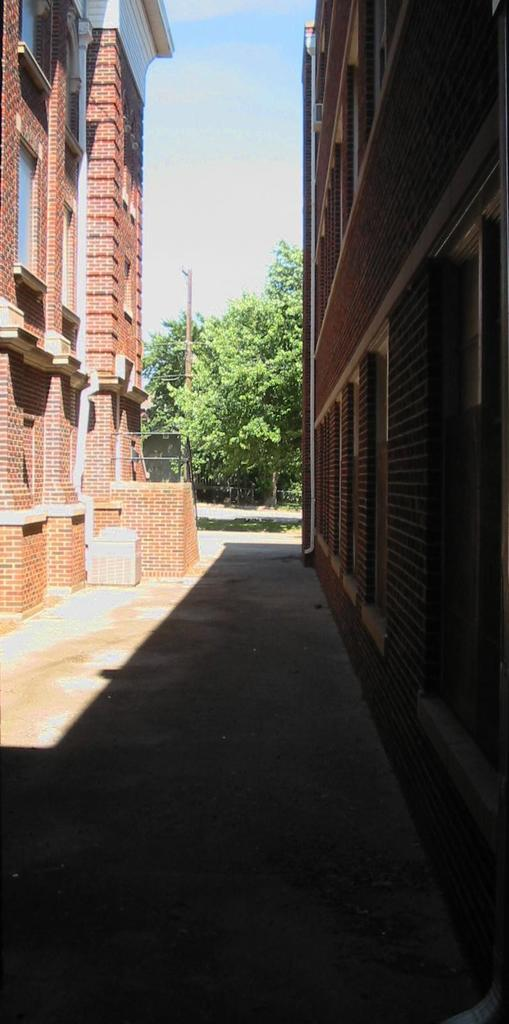What type of structures are present in the image? There are buildings with windows in the image. What feature can be seen on the buildings? The buildings have railings. What can be seen in the background of the image? There is a group of trees and the sky visible in the background of the image. How many flowers are present in the image? There are no flowers visible in the image. 